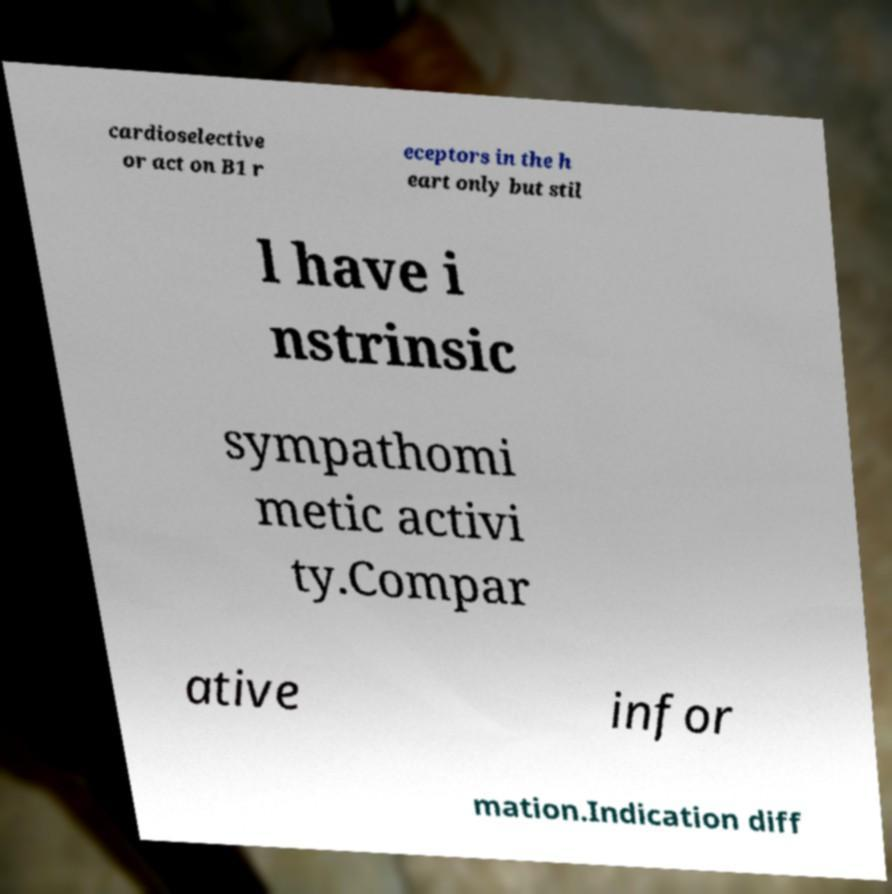For documentation purposes, I need the text within this image transcribed. Could you provide that? cardioselective or act on B1 r eceptors in the h eart only but stil l have i nstrinsic sympathomi metic activi ty.Compar ative infor mation.Indication diff 